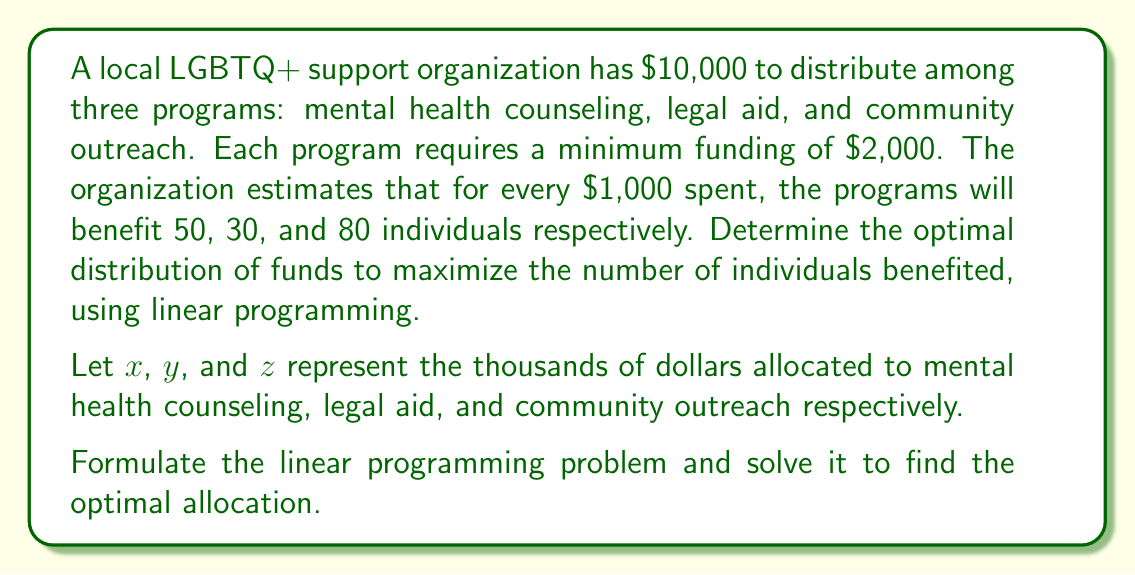Give your solution to this math problem. Step 1: Formulate the objective function
Maximize: $50x + 30y + 80z$

Step 2: Identify the constraints
1. Total budget: $x + y + z \leq 10$
2. Minimum funding for each program: $x \geq 2$, $y \geq 2$, $z \geq 2$
3. Non-negativity: $x, y, z \geq 0$

Step 3: Set up the linear programming problem
Maximize: $50x + 30y + 80z$
Subject to:
$$\begin{align}
x + y + z &\leq 10 \\
x &\geq 2 \\
y &\geq 2 \\
z &\geq 2 \\
x, y, z &\geq 0
\end{align}$$

Step 4: Solve using the corner point method
The feasible region is a triangle on the plane $x + y + z = 10$ bounded by $x = 2$, $y = 2$, and $z = 2$.

Corner points:
1. (2, 2, 6)
2. (2, 6, 2)
3. (6, 2, 2)

Evaluate the objective function at each point:
1. $50(2) + 30(2) + 80(6) = 660$
2. $50(2) + 30(6) + 80(2) = 380$
3. $50(6) + 30(2) + 80(2) = 460$

Step 5: Determine the optimal solution
The maximum value occurs at point (2, 2, 6), which corresponds to:
- $2,000 for mental health counseling
- $2,000 for legal aid
- $6,000 for community outreach

This allocation will benefit 660 individuals.
Answer: Mental health counseling: $2,000; Legal aid: $2,000; Community outreach: $6,000 